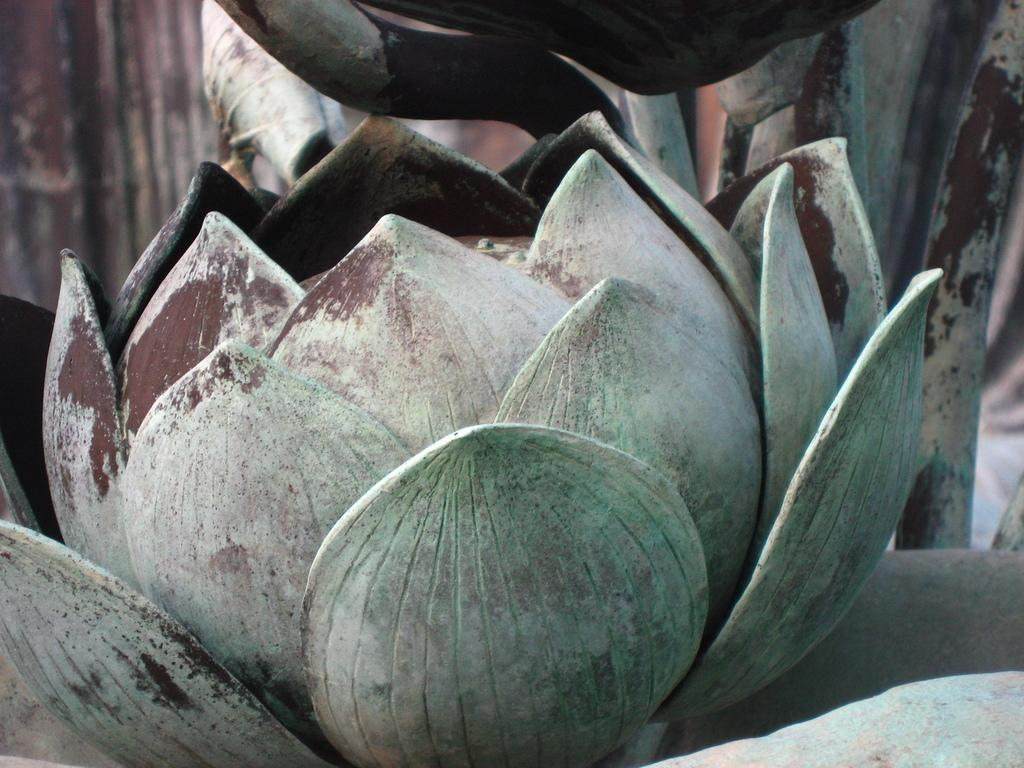What type of plant is featured in the image? There is an agave azul flower in the image. How many brothers are teaching in the memory depicted in the image? There are no brothers, teaching, or memories present in the image; it features an agave azul flower. 